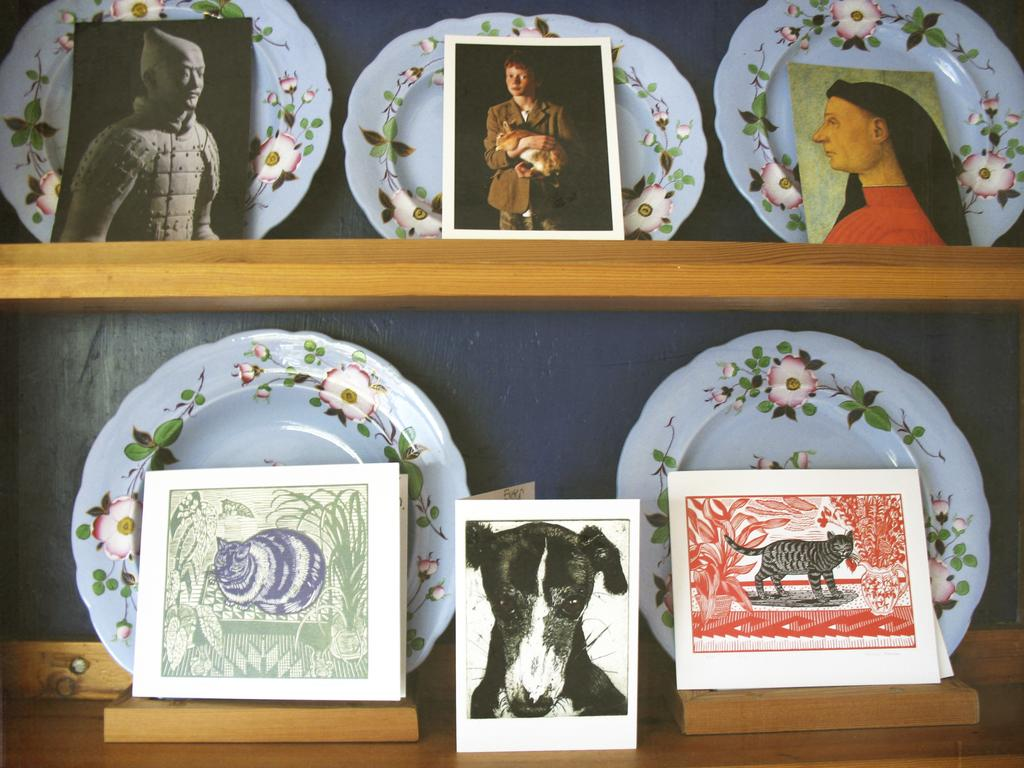What objects are on shelves in the image? There are plates and photographs on shelves in the image. What type of items are the plates used for? The plates are likely used for serving food, although their specific use is not explicitly stated in the facts. What can be seen on the photographs? The content of the photographs is not specified in the facts, so we cannot determine what is depicted on them. What type of hat is visible on the shelf in the image? There is: There is no hat present on the shelf in the image. 